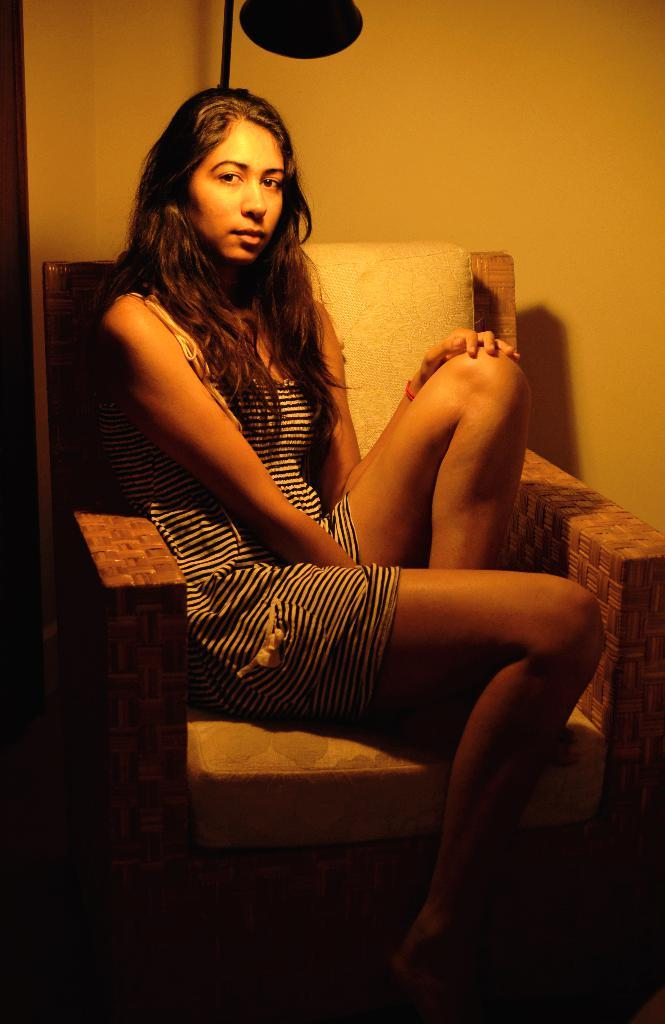What is the woman doing in the image? The woman is seated on a chair in the image. Can you describe the lighting in the image? There is a light in the image. What is the background of the image made of? There is a wall in the image. What type of silk is draped over the boats in the image? There are no boats or silk present in the image. 